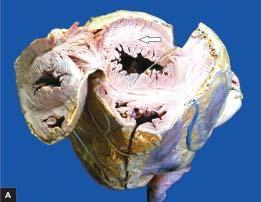s weight of the heart increased?
Answer the question using a single word or phrase. Yes 